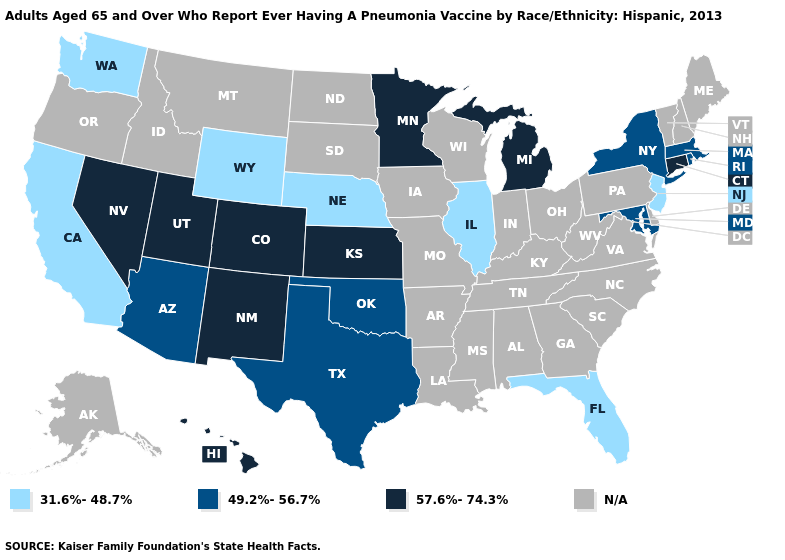Among the states that border Delaware , which have the lowest value?
Be succinct. New Jersey. What is the highest value in the MidWest ?
Be succinct. 57.6%-74.3%. Name the states that have a value in the range N/A?
Quick response, please. Alabama, Alaska, Arkansas, Delaware, Georgia, Idaho, Indiana, Iowa, Kentucky, Louisiana, Maine, Mississippi, Missouri, Montana, New Hampshire, North Carolina, North Dakota, Ohio, Oregon, Pennsylvania, South Carolina, South Dakota, Tennessee, Vermont, Virginia, West Virginia, Wisconsin. What is the value of North Dakota?
Answer briefly. N/A. Does Colorado have the highest value in the USA?
Quick response, please. Yes. What is the value of Nebraska?
Give a very brief answer. 31.6%-48.7%. Does Kansas have the highest value in the USA?
Quick response, please. Yes. What is the value of Kentucky?
Keep it brief. N/A. What is the lowest value in the South?
Short answer required. 31.6%-48.7%. Does California have the highest value in the West?
Give a very brief answer. No. Name the states that have a value in the range 31.6%-48.7%?
Write a very short answer. California, Florida, Illinois, Nebraska, New Jersey, Washington, Wyoming. Does the map have missing data?
Give a very brief answer. Yes. What is the highest value in the South ?
Concise answer only. 49.2%-56.7%. 